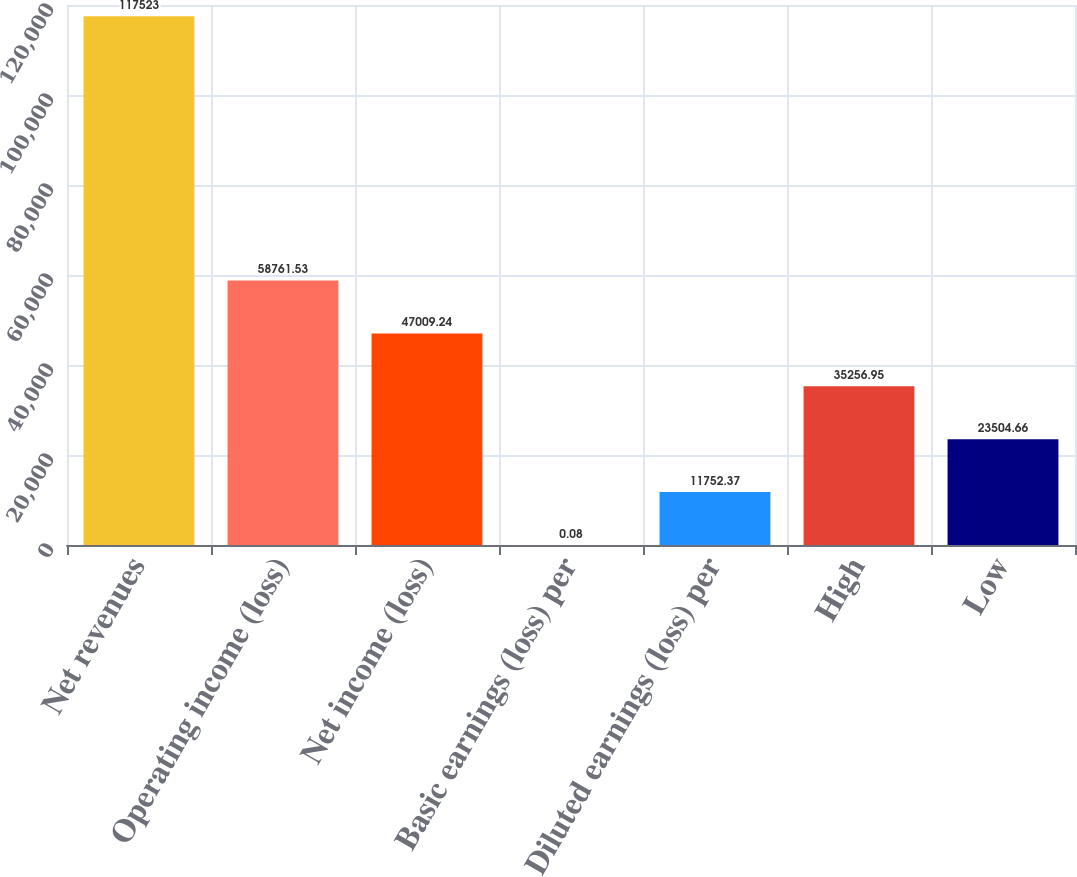<chart> <loc_0><loc_0><loc_500><loc_500><bar_chart><fcel>Net revenues<fcel>Operating income (loss)<fcel>Net income (loss)<fcel>Basic earnings (loss) per<fcel>Diluted earnings (loss) per<fcel>High<fcel>Low<nl><fcel>117523<fcel>58761.5<fcel>47009.2<fcel>0.08<fcel>11752.4<fcel>35256.9<fcel>23504.7<nl></chart> 